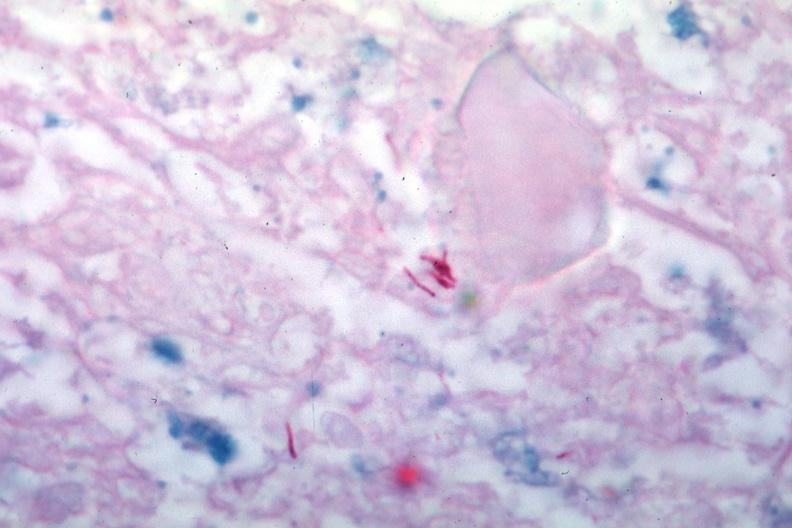does this image show acid fast stain several typical mycobacteria?
Answer the question using a single word or phrase. Yes 